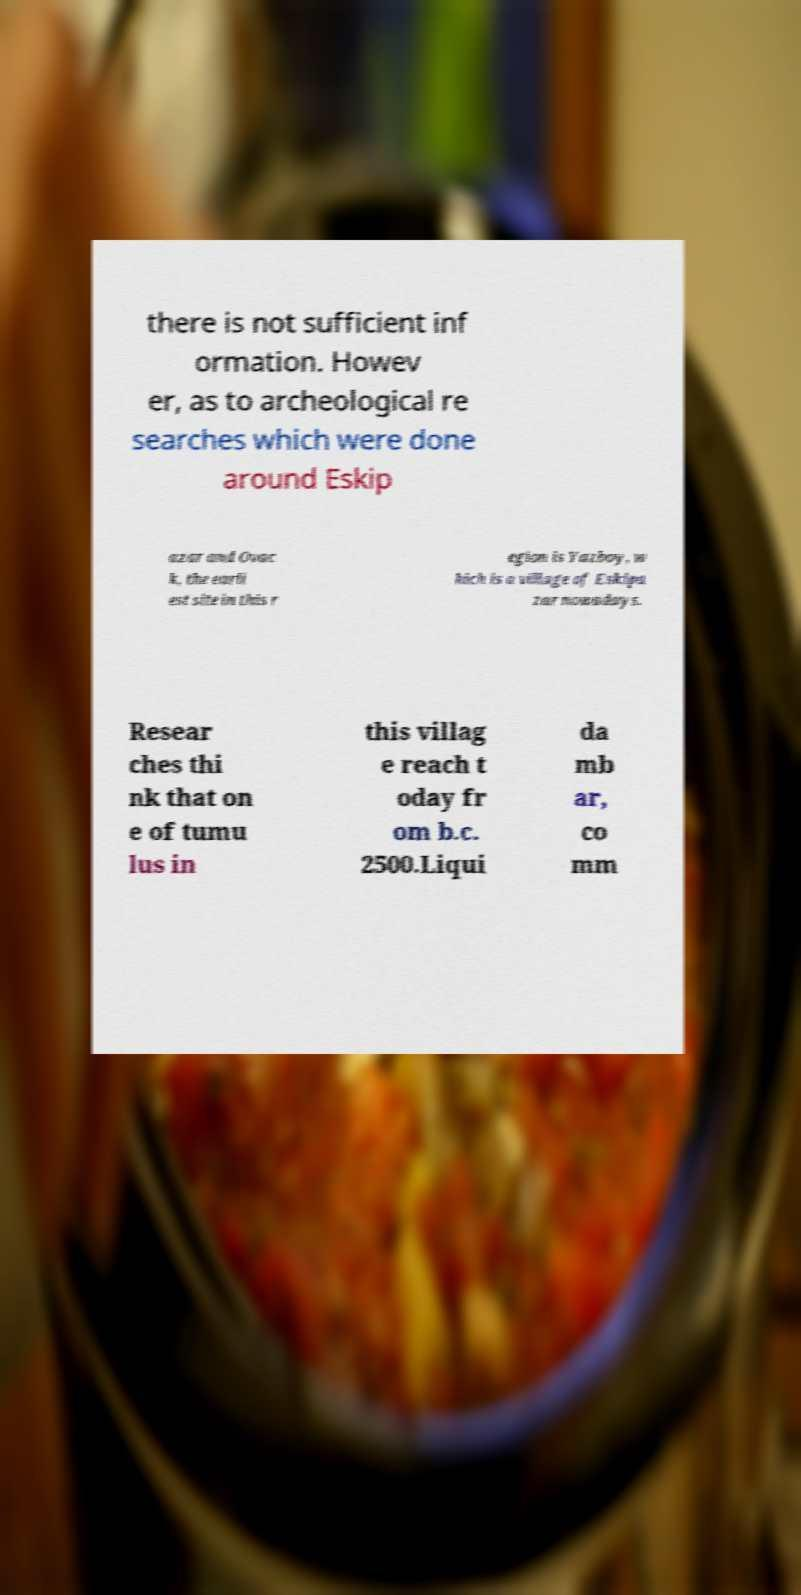I need the written content from this picture converted into text. Can you do that? there is not sufficient inf ormation. Howev er, as to archeological re searches which were done around Eskip azar and Ovac k, the earli est site in this r egion is Yazboy, w hich is a village of Eskipa zar nowadays. Resear ches thi nk that on e of tumu lus in this villag e reach t oday fr om b.c. 2500.Liqui da mb ar, co mm 